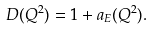Convert formula to latex. <formula><loc_0><loc_0><loc_500><loc_500>D ( Q ^ { 2 } ) = 1 + a _ { E } ( Q ^ { 2 } ) .</formula> 